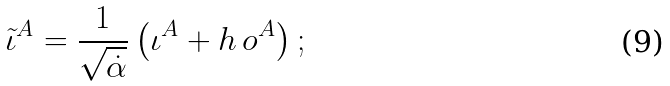Convert formula to latex. <formula><loc_0><loc_0><loc_500><loc_500>\tilde { \iota } ^ { A } = \frac { 1 } { \sqrt { \dot { \alpha } } } \left ( \iota ^ { A } + h \, o ^ { A } \right ) ;</formula> 